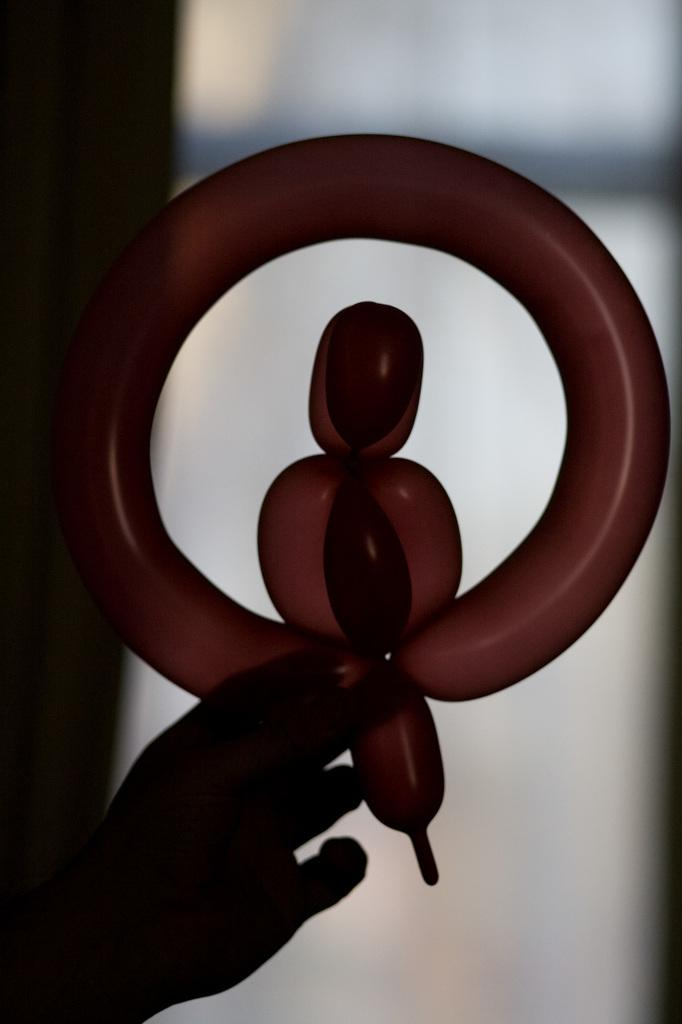What can be seen in the person's hand in the image? The hand is holding a balloon. What is the shape of the balloon? The balloon is in a shape. How would you describe the background of the image? The background of the image appears blurred. What type of selection process is being conducted in the image? There is no indication of a selection process in the image; it features a person's hand holding a balloon. What time is displayed on the clock in the image? There is no clock present in the image. 